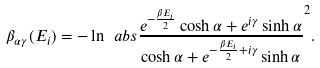Convert formula to latex. <formula><loc_0><loc_0><loc_500><loc_500>\beta _ { \alpha \gamma } ( E _ { i } ) = - \ln \ a b s { \frac { e ^ { - \frac { \beta E _ { i } } { 2 } } \cosh \alpha + e ^ { i \gamma } \sinh \alpha } { \cosh \alpha + e ^ { - \frac { \beta E _ { i } } { 2 } + i \gamma } \sinh \alpha } } ^ { 2 } .</formula> 